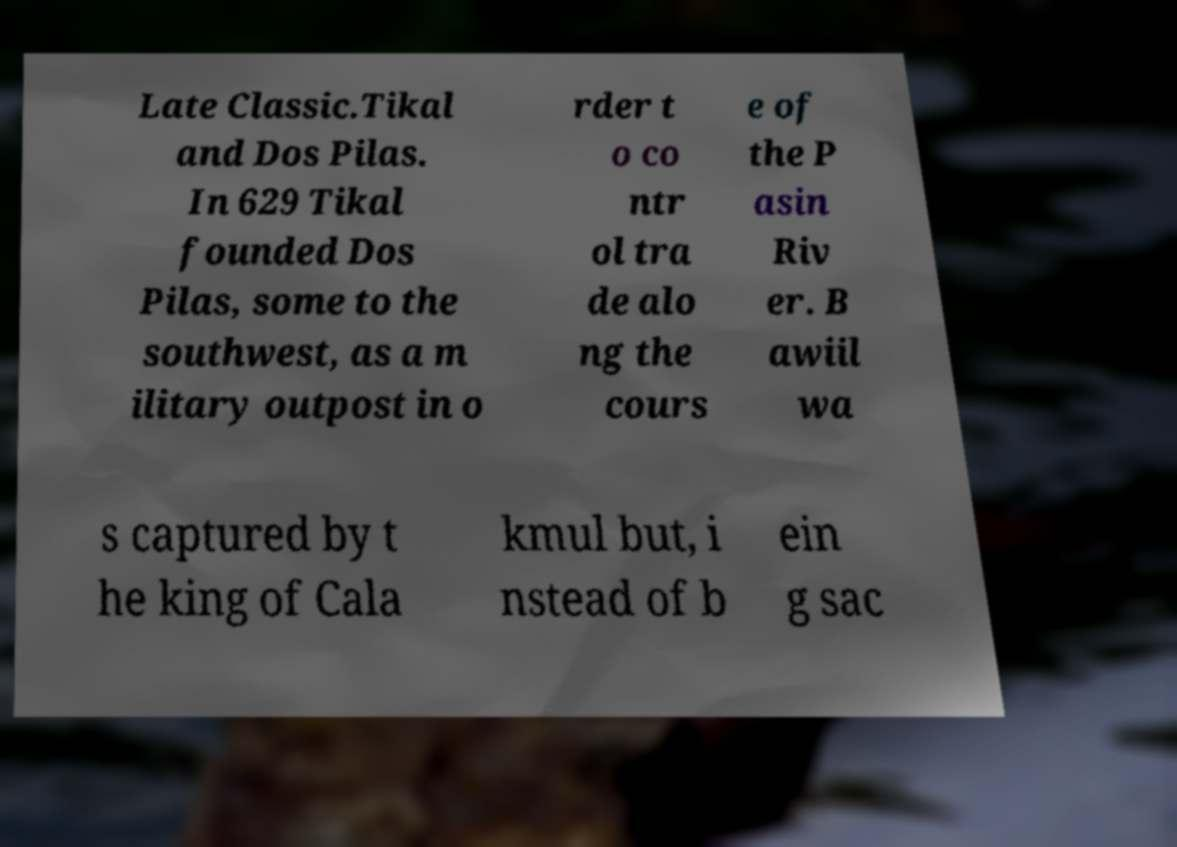I need the written content from this picture converted into text. Can you do that? Late Classic.Tikal and Dos Pilas. In 629 Tikal founded Dos Pilas, some to the southwest, as a m ilitary outpost in o rder t o co ntr ol tra de alo ng the cours e of the P asin Riv er. B awiil wa s captured by t he king of Cala kmul but, i nstead of b ein g sac 